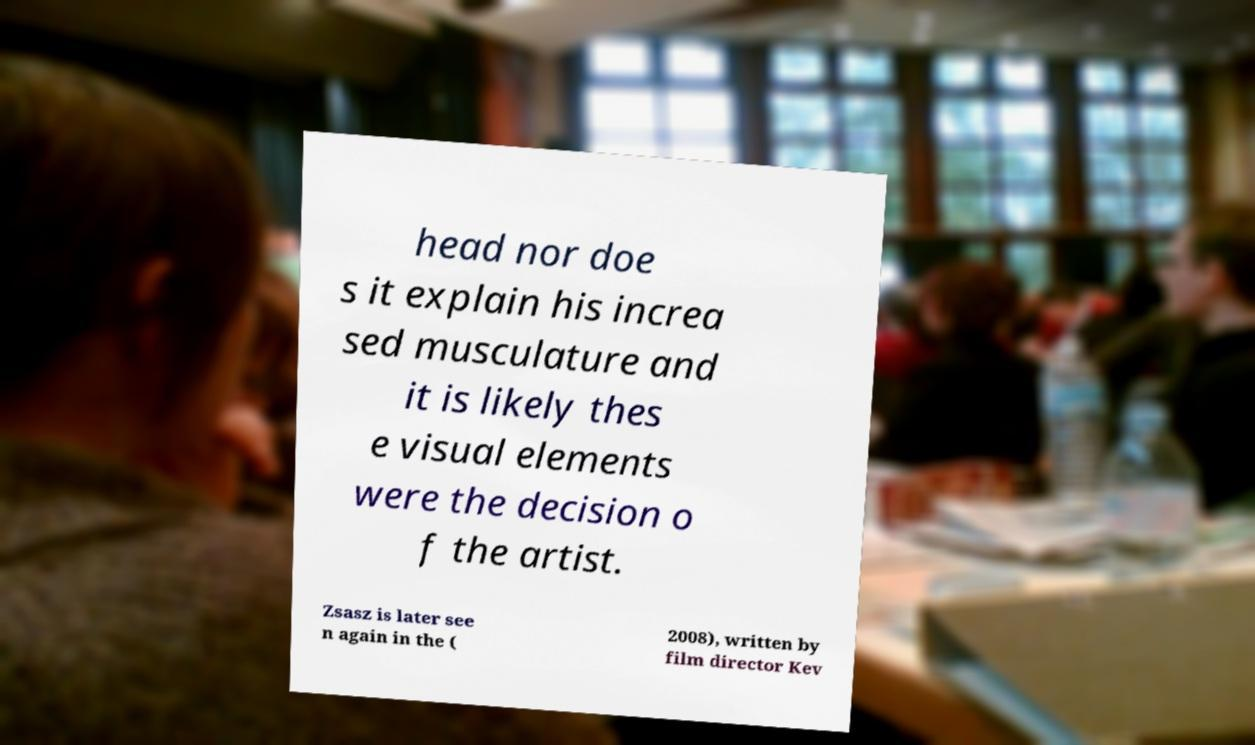Please identify and transcribe the text found in this image. head nor doe s it explain his increa sed musculature and it is likely thes e visual elements were the decision o f the artist. Zsasz is later see n again in the ( 2008), written by film director Kev 